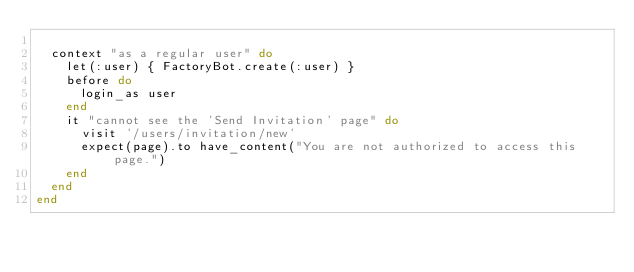Convert code to text. <code><loc_0><loc_0><loc_500><loc_500><_Ruby_>
  context "as a regular user" do
    let(:user) { FactoryBot.create(:user) }
    before do
      login_as user
    end
    it "cannot see the 'Send Invitation' page" do
      visit '/users/invitation/new'
      expect(page).to have_content("You are not authorized to access this page.")
    end
  end
end
</code> 